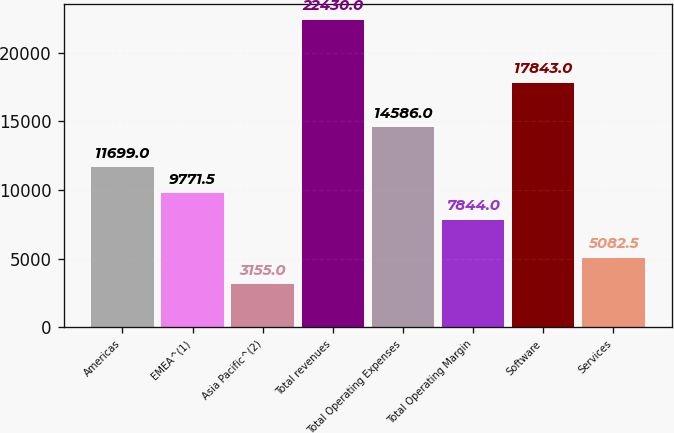Convert chart to OTSL. <chart><loc_0><loc_0><loc_500><loc_500><bar_chart><fcel>Americas<fcel>EMEA^(1)<fcel>Asia Pacific^(2)<fcel>Total revenues<fcel>Total Operating Expenses<fcel>Total Operating Margin<fcel>Software<fcel>Services<nl><fcel>11699<fcel>9771.5<fcel>3155<fcel>22430<fcel>14586<fcel>7844<fcel>17843<fcel>5082.5<nl></chart> 